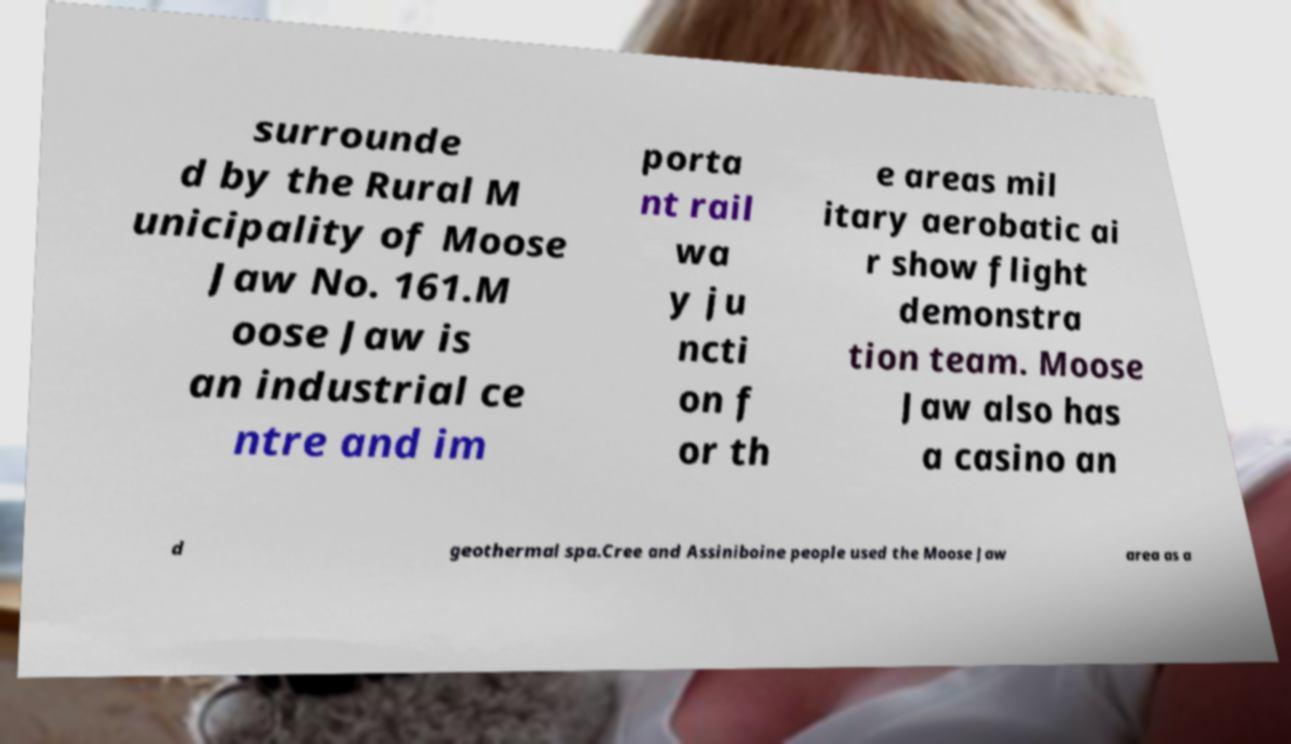Could you extract and type out the text from this image? surrounde d by the Rural M unicipality of Moose Jaw No. 161.M oose Jaw is an industrial ce ntre and im porta nt rail wa y ju ncti on f or th e areas mil itary aerobatic ai r show flight demonstra tion team. Moose Jaw also has a casino an d geothermal spa.Cree and Assiniboine people used the Moose Jaw area as a 